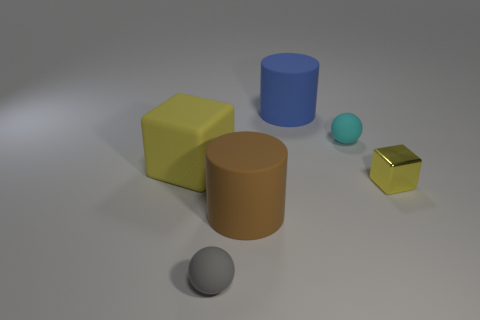Add 4 brown objects. How many objects exist? 10 Subtract 2 cylinders. How many cylinders are left? 0 Subtract all small spheres. Subtract all large matte cylinders. How many objects are left? 2 Add 3 brown things. How many brown things are left? 4 Add 3 small gray metal spheres. How many small gray metal spheres exist? 3 Subtract 0 blue spheres. How many objects are left? 6 Subtract all purple cylinders. Subtract all brown balls. How many cylinders are left? 2 